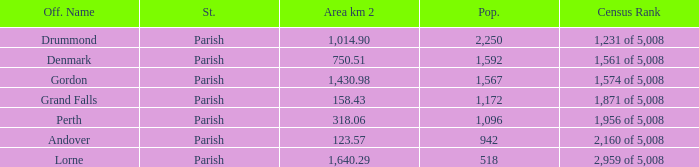What is the area of the parish with a population larger than 1,172 and a census ranking of 1,871 of 5,008? 0.0. 